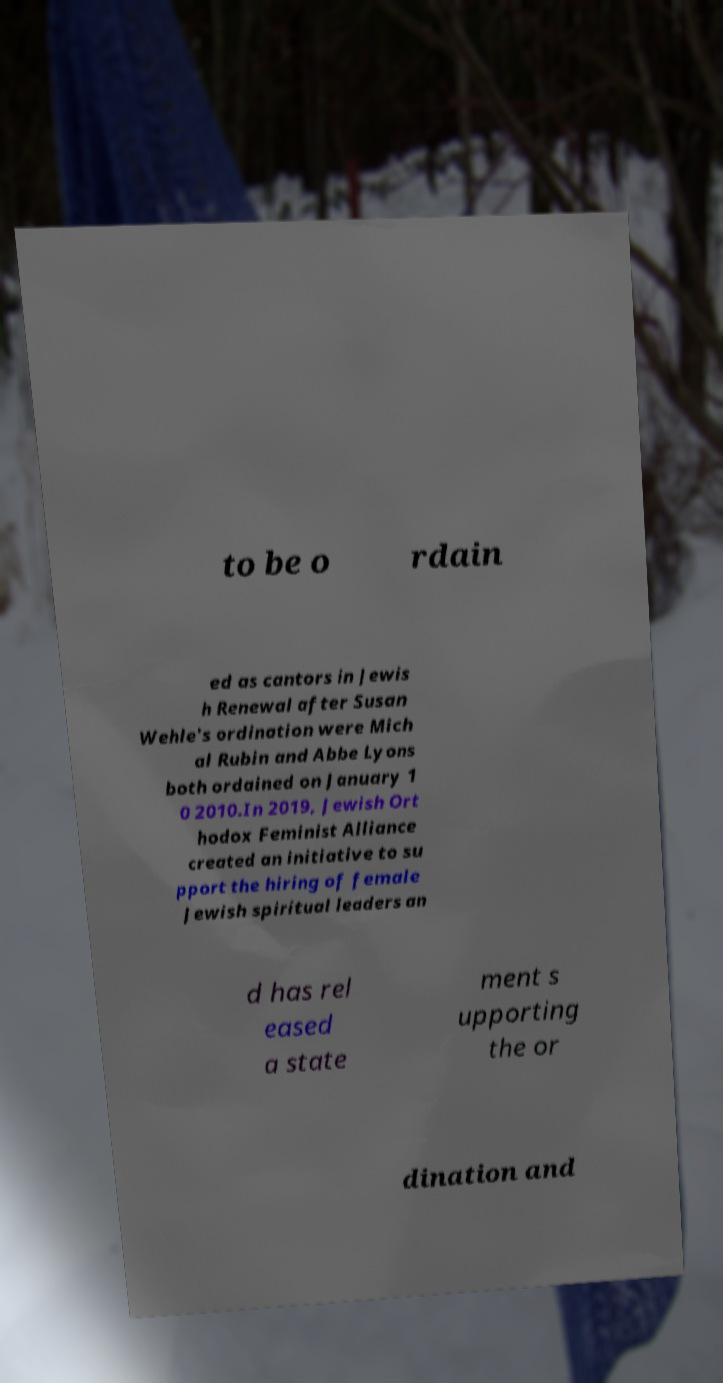Could you extract and type out the text from this image? to be o rdain ed as cantors in Jewis h Renewal after Susan Wehle's ordination were Mich al Rubin and Abbe Lyons both ordained on January 1 0 2010.In 2019, Jewish Ort hodox Feminist Alliance created an initiative to su pport the hiring of female Jewish spiritual leaders an d has rel eased a state ment s upporting the or dination and 